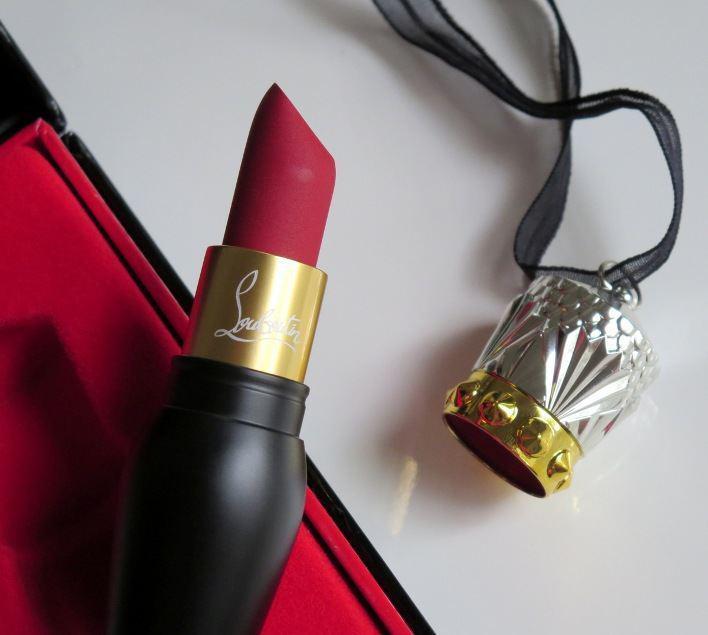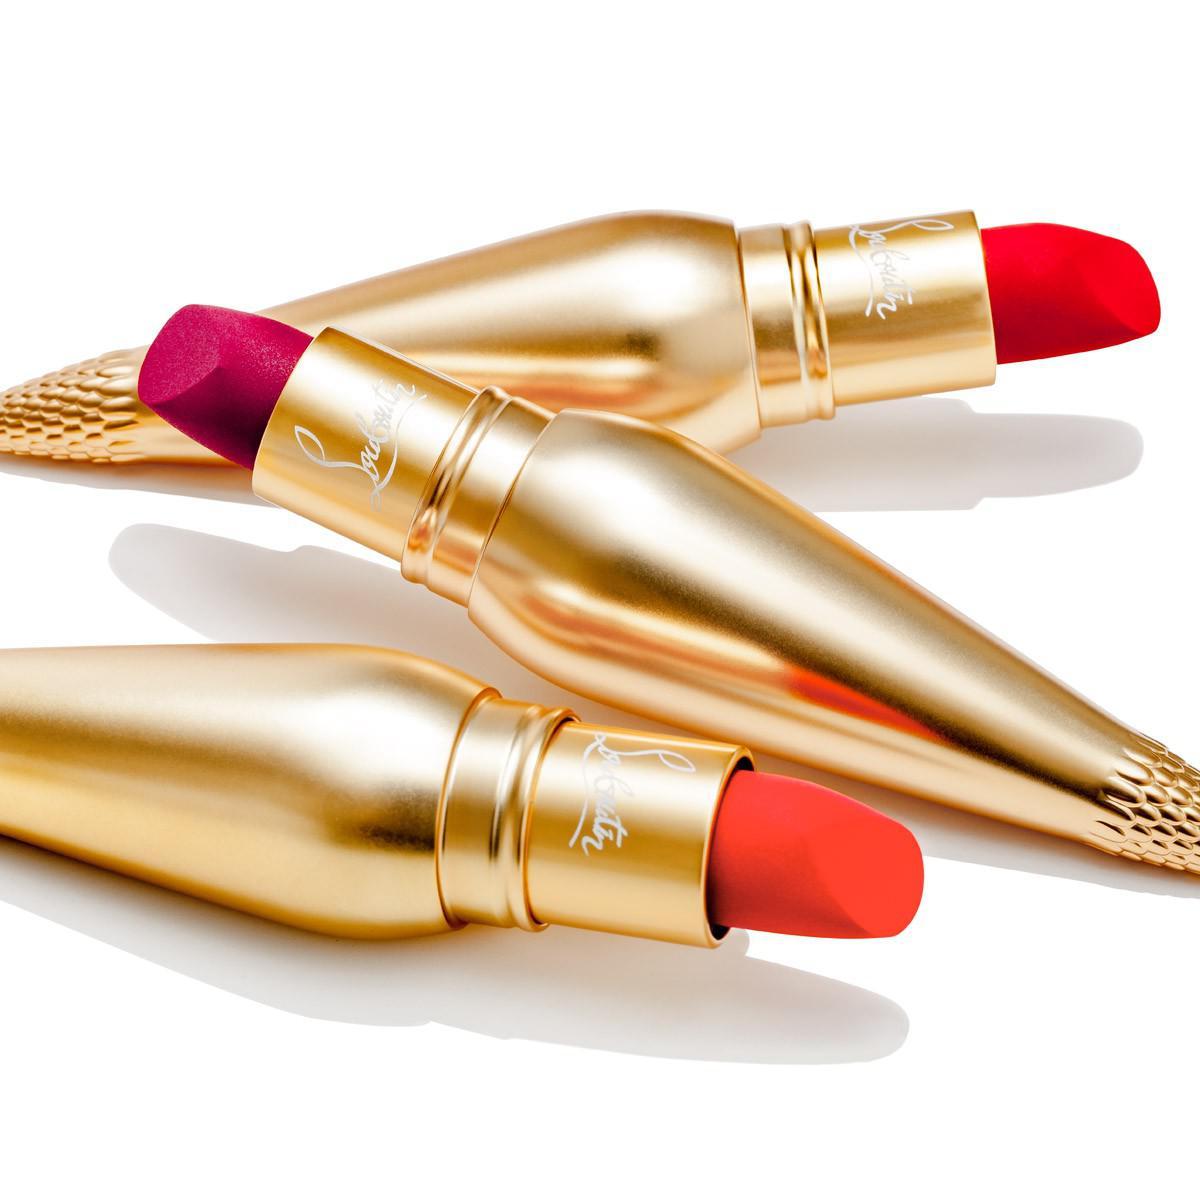The first image is the image on the left, the second image is the image on the right. For the images displayed, is the sentence "There are three lipsticks with black cases in at least one image." factually correct? Answer yes or no. No. The first image is the image on the left, the second image is the image on the right. Examine the images to the left and right. Is the description "Lipstick in a black and gold vial shaped tube is balanced upright on the tip and has a cap that resembles a crown set down next to it." accurate? Answer yes or no. No. 